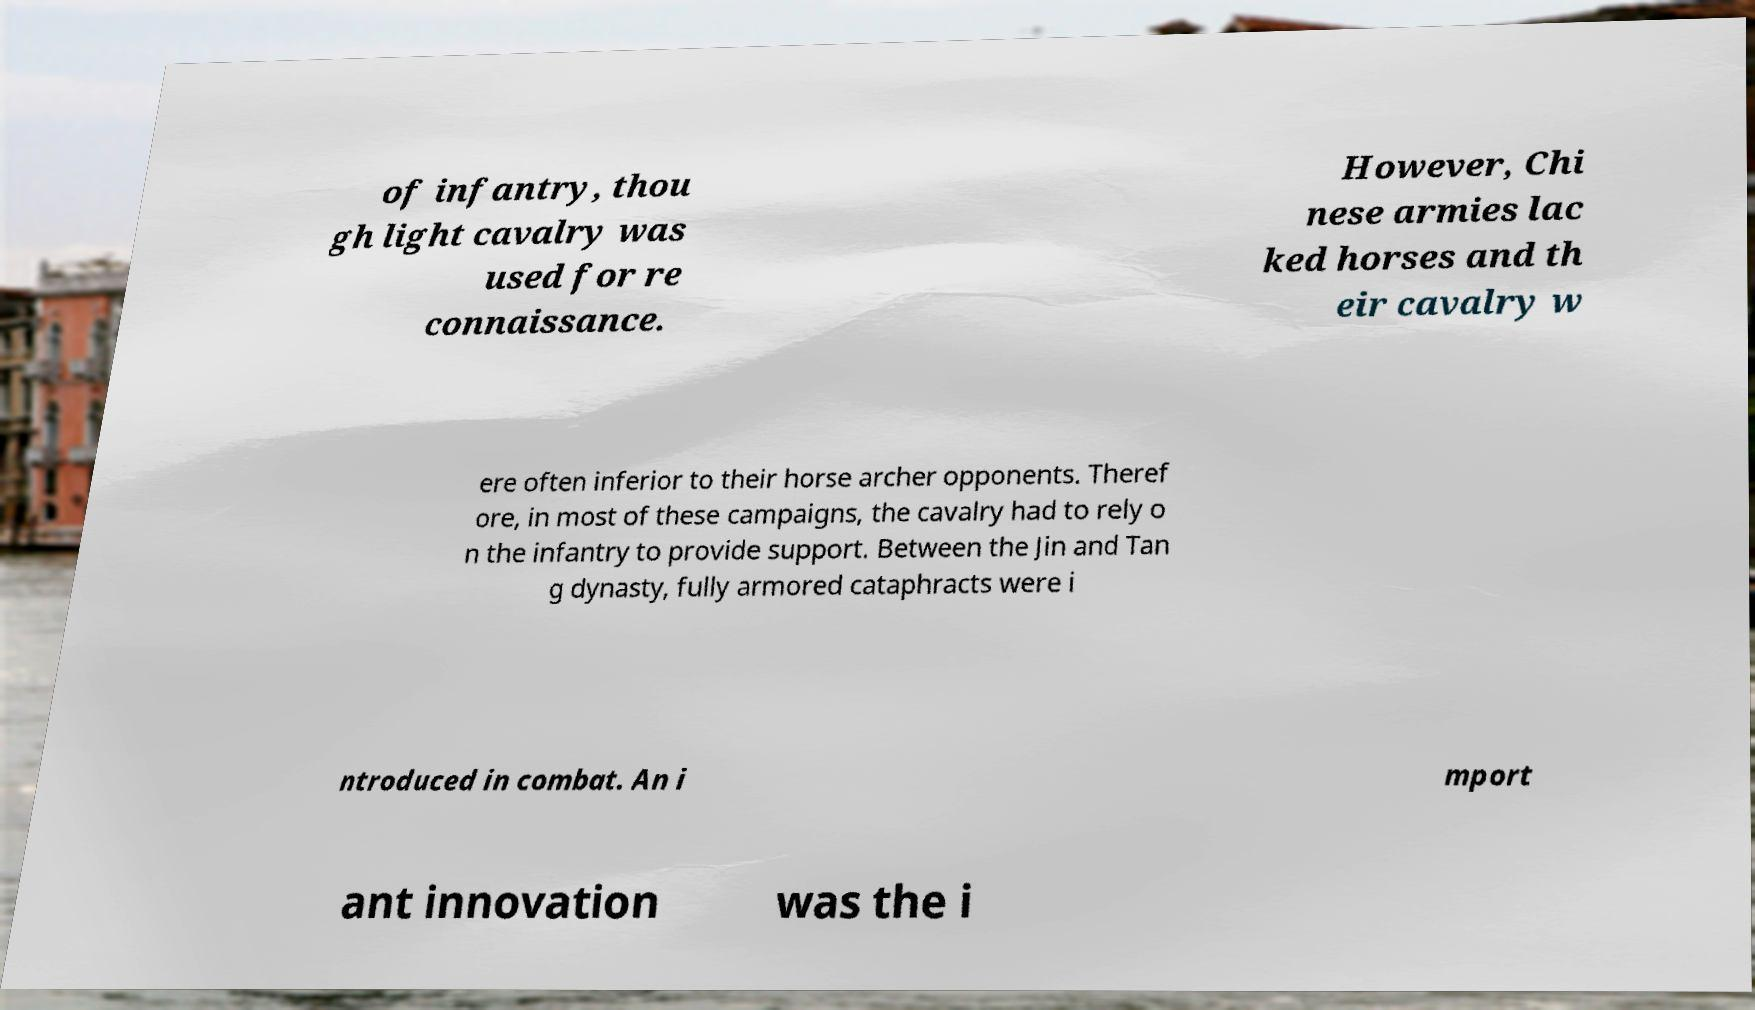For documentation purposes, I need the text within this image transcribed. Could you provide that? of infantry, thou gh light cavalry was used for re connaissance. However, Chi nese armies lac ked horses and th eir cavalry w ere often inferior to their horse archer opponents. Theref ore, in most of these campaigns, the cavalry had to rely o n the infantry to provide support. Between the Jin and Tan g dynasty, fully armored cataphracts were i ntroduced in combat. An i mport ant innovation was the i 